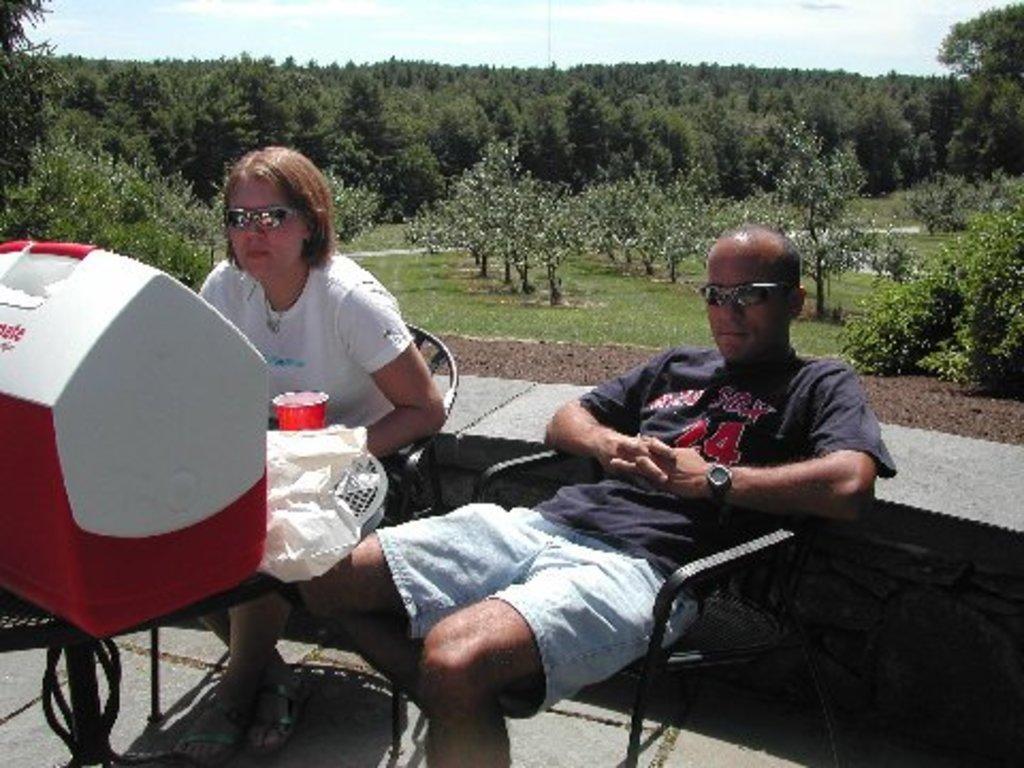Please provide a concise description of this image. In this picture we can see persons sitting on chairs,here we can see a box and in the background we can see trees,sky. 